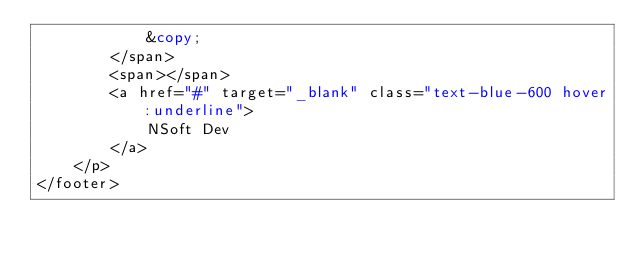Convert code to text. <code><loc_0><loc_0><loc_500><loc_500><_PHP_>            &copy;
        </span>
        <span></span>
        <a href="#" target="_blank" class="text-blue-600 hover:underline">
            NSoft Dev
        </a>
    </p>
</footer></code> 